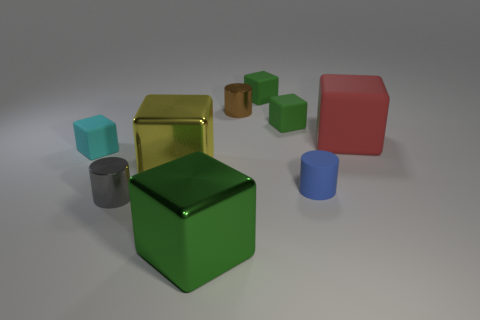Do the red thing on the right side of the tiny brown cylinder and the cylinder that is behind the yellow metal cube have the same material?
Offer a very short reply. No. There is a red object that is right of the brown metallic cylinder; what size is it?
Keep it short and to the point. Large. There is a tiny cyan thing that is the same shape as the large red matte thing; what is it made of?
Provide a short and direct response. Rubber. The big object that is behind the tiny cyan matte cube has what shape?
Ensure brevity in your answer.  Cube. What number of large blue matte things are the same shape as the red rubber object?
Provide a succinct answer. 0. Are there an equal number of large yellow metallic objects that are in front of the tiny blue thing and tiny green matte blocks that are in front of the large red rubber thing?
Make the answer very short. Yes. Is there a brown object made of the same material as the small blue cylinder?
Your answer should be very brief. No. Is the material of the gray thing the same as the small blue cylinder?
Ensure brevity in your answer.  No. How many green things are either tiny objects or large objects?
Offer a terse response. 3. Is the number of red things to the right of the gray object greater than the number of big rubber balls?
Offer a very short reply. Yes. 